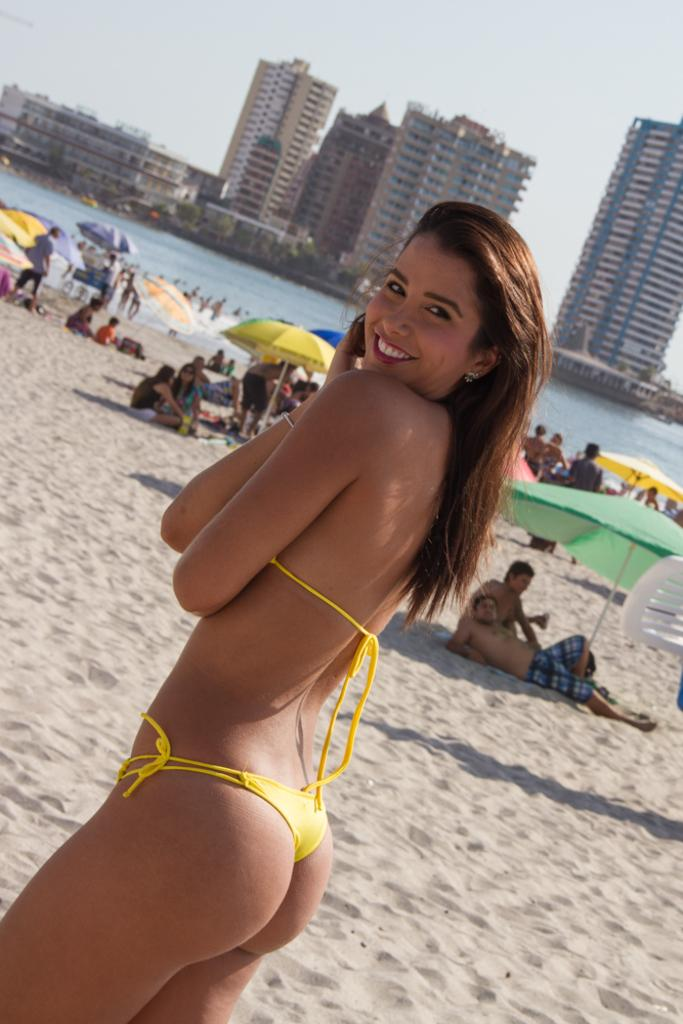What natural element is present in the image? There is water in the image. What type of terrain can be seen in the image? There is sand in the image. What is visible at the top of the image? The sky is visible at the top of the image. How many people are in the image? There is a group of people in the image. What might be used for protection from the sun in the image? Umbrellas are present in the image. What type of structures can be seen in the background of the image? There are buildings in the background of the image. Where is the zebra located in the image? There is no zebra present in the image. What type of exchange is taking place between the people in the image? The image does not provide information about any exchange between the people. 